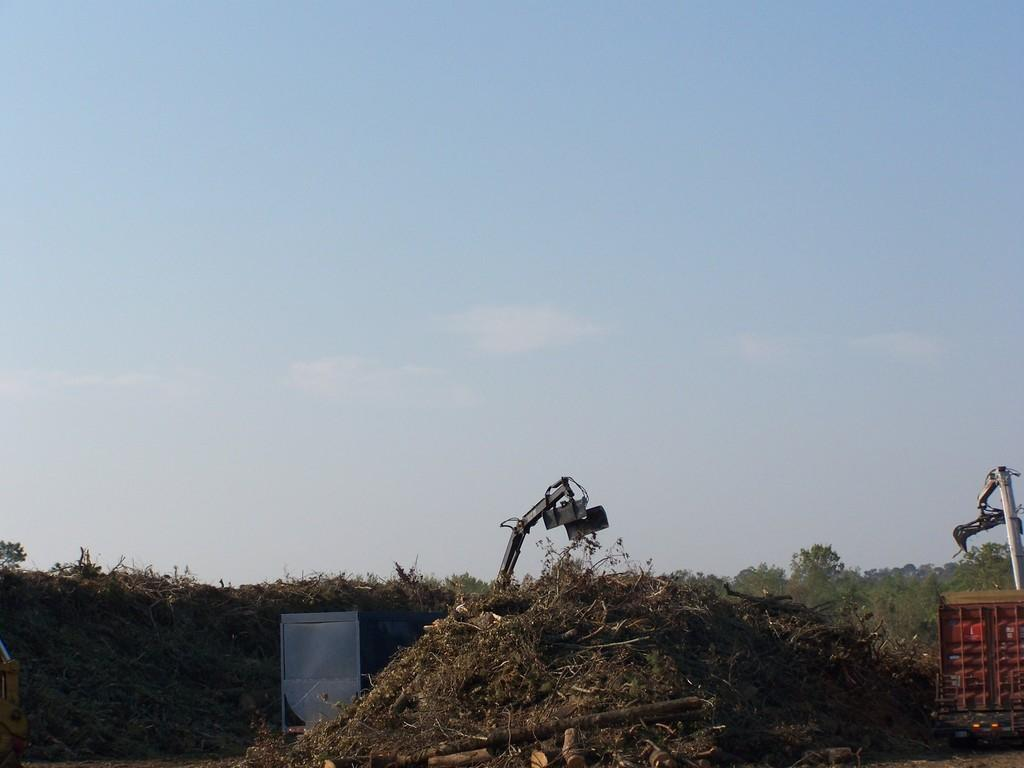What animals can be seen in the image? There are two cranes in the image. What is in front of the cranes? There is dried grass in front of the cranes. What can be seen in the background of the image? There are plants in the background of the image. What is the color of the plants? The plants are green in color. What is visible above the cranes and plants? The sky is visible in the image. What colors can be seen in the sky? The sky has both white and blue colors. How many eggs are being held by the cranes in the image? There are no eggs visible in the image; the cranes are not holding anything. What type of string can be seen connecting the cranes in the image? There is no string connecting the cranes in the image. 